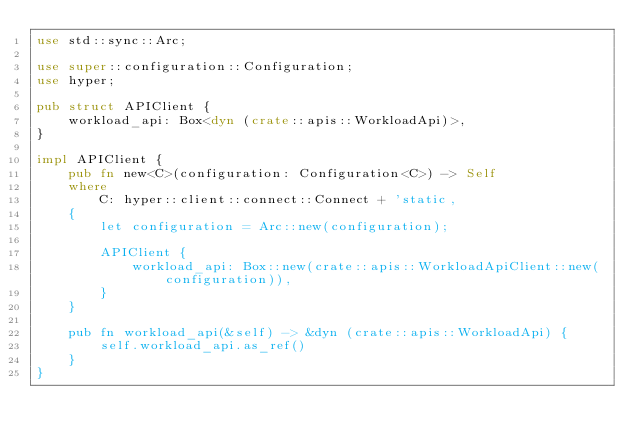Convert code to text. <code><loc_0><loc_0><loc_500><loc_500><_Rust_>use std::sync::Arc;

use super::configuration::Configuration;
use hyper;

pub struct APIClient {
    workload_api: Box<dyn (crate::apis::WorkloadApi)>,
}

impl APIClient {
    pub fn new<C>(configuration: Configuration<C>) -> Self
    where
        C: hyper::client::connect::Connect + 'static,
    {
        let configuration = Arc::new(configuration);

        APIClient {
            workload_api: Box::new(crate::apis::WorkloadApiClient::new(configuration)),
        }
    }

    pub fn workload_api(&self) -> &dyn (crate::apis::WorkloadApi) {
        self.workload_api.as_ref()
    }
}
</code> 